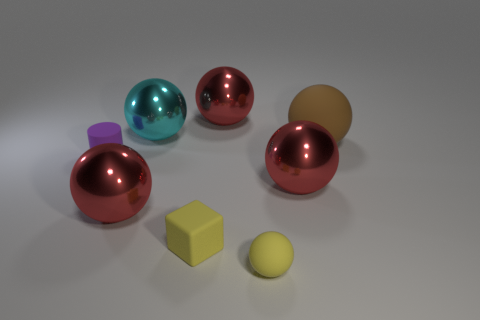Is there any other thing that is the same shape as the small purple rubber thing?
Give a very brief answer. No. Is the shape of the purple matte object the same as the big cyan thing?
Keep it short and to the point. No. Is the number of big cyan objects in front of the tiny yellow matte ball the same as the number of metallic things on the right side of the small yellow block?
Make the answer very short. No. How many other things are there of the same material as the large brown ball?
Make the answer very short. 3. What number of big things are either cyan shiny things or rubber cylinders?
Keep it short and to the point. 1. Are there an equal number of cyan things in front of the cyan sphere and large balls?
Offer a terse response. No. There is a yellow rubber thing on the left side of the tiny yellow matte sphere; are there any small yellow things behind it?
Provide a short and direct response. No. What number of other things are there of the same color as the small matte cylinder?
Ensure brevity in your answer.  0. What is the color of the large matte object?
Ensure brevity in your answer.  Brown. There is a red thing that is both in front of the large cyan sphere and right of the big cyan metal thing; what is its size?
Provide a short and direct response. Large. 